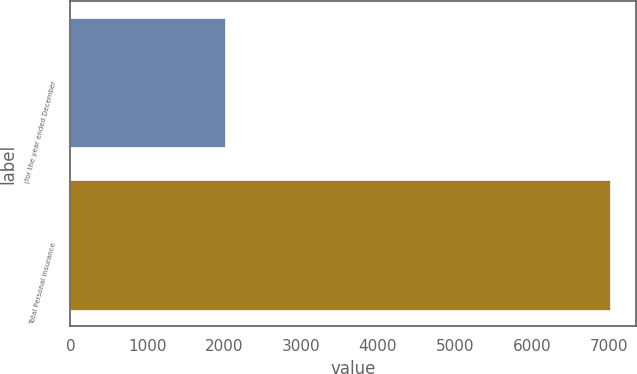Convert chart to OTSL. <chart><loc_0><loc_0><loc_500><loc_500><bar_chart><fcel>(for the year ended December<fcel>Total Personal Insurance<nl><fcel>2006<fcel>7011<nl></chart> 